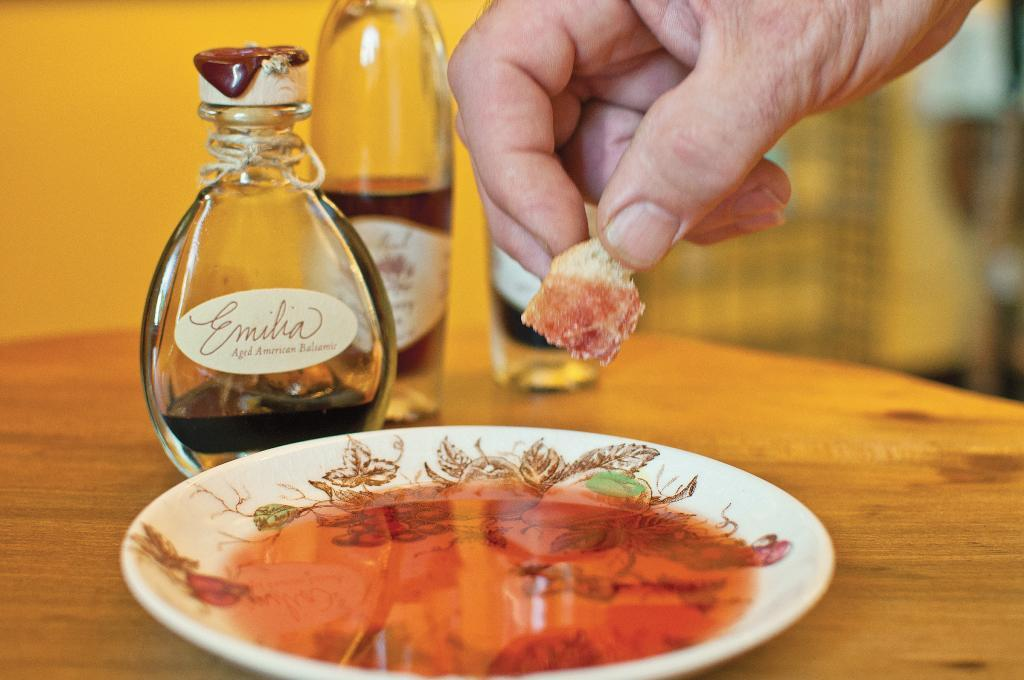<image>
Relay a brief, clear account of the picture shown. A hand is dipping bread into some Emilia aged American Balsamic dip 